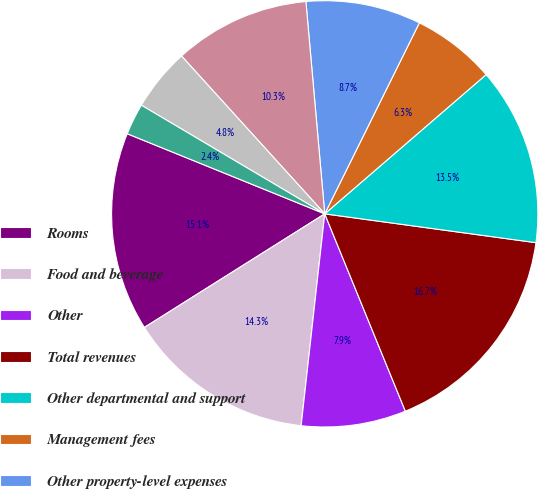Convert chart. <chart><loc_0><loc_0><loc_500><loc_500><pie_chart><fcel>Rooms<fcel>Food and beverage<fcel>Other<fcel>Total revenues<fcel>Other departmental and support<fcel>Management fees<fcel>Other property-level expenses<fcel>Depreciation and amortization<fcel>Corporate and other expenses<fcel>Gain on insurance and business<nl><fcel>15.08%<fcel>14.29%<fcel>7.94%<fcel>16.67%<fcel>13.49%<fcel>6.35%<fcel>8.73%<fcel>10.32%<fcel>4.76%<fcel>2.38%<nl></chart> 